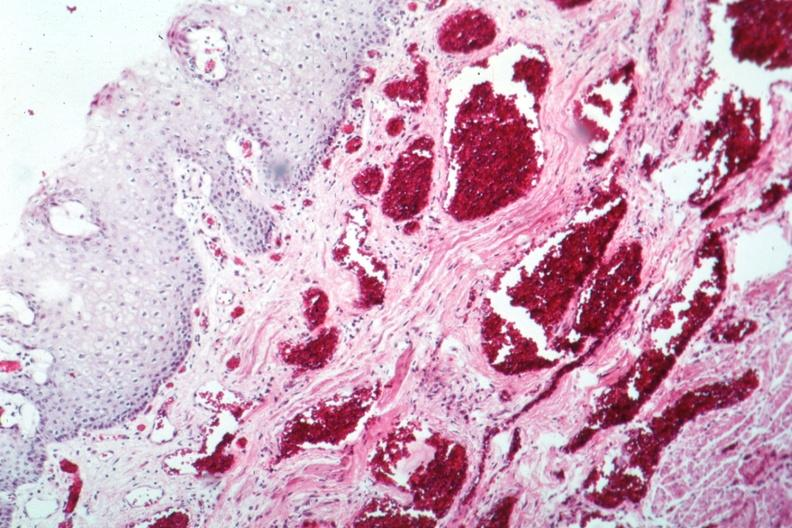where is this from?
Answer the question using a single word or phrase. Gastrointestinal system 